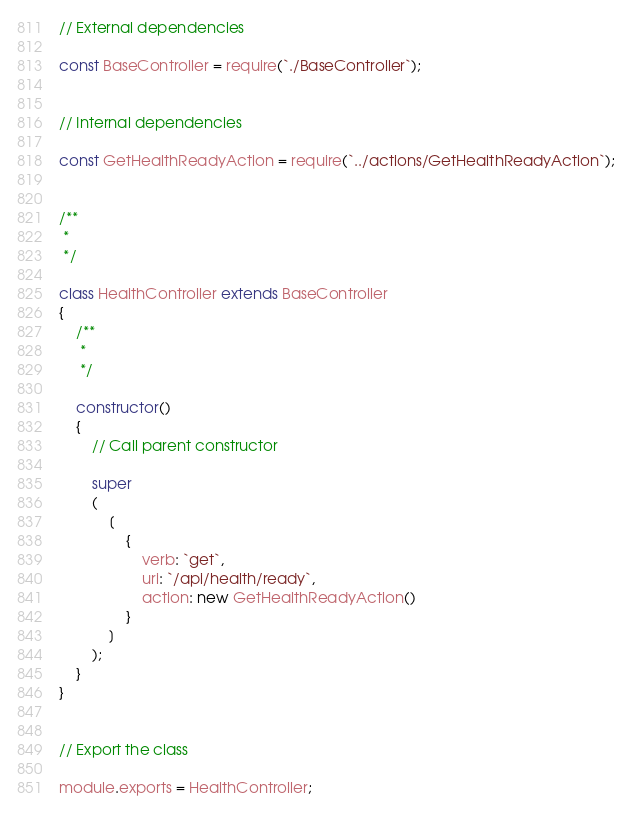<code> <loc_0><loc_0><loc_500><loc_500><_JavaScript_>// External dependencies

const BaseController = require(`./BaseController`);


// Internal dependencies

const GetHealthReadyAction = require(`../actions/GetHealthReadyAction`);


/**
 *
 */

class HealthController extends BaseController
{
	/**
	 *
	 */

	constructor()
	{
		// Call parent constructor

		super
		(
			[
				{
					verb: `get`,
					uri: `/api/health/ready`,
					action: new GetHealthReadyAction()
				}
			]
		);
	}
}


// Export the class

module.exports = HealthController;
</code> 